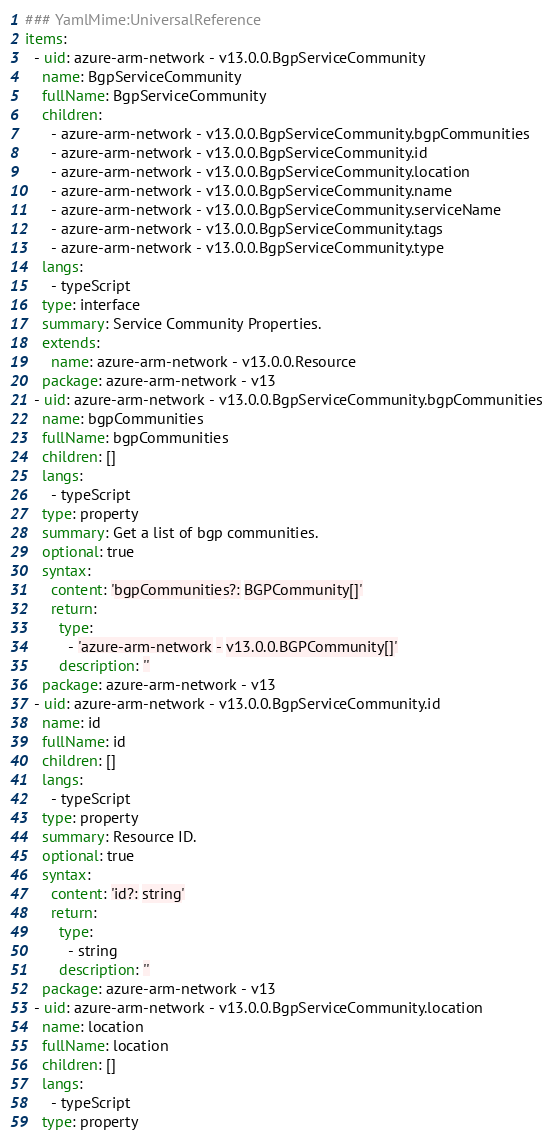<code> <loc_0><loc_0><loc_500><loc_500><_YAML_>### YamlMime:UniversalReference
items:
  - uid: azure-arm-network - v13.0.0.BgpServiceCommunity
    name: BgpServiceCommunity
    fullName: BgpServiceCommunity
    children:
      - azure-arm-network - v13.0.0.BgpServiceCommunity.bgpCommunities
      - azure-arm-network - v13.0.0.BgpServiceCommunity.id
      - azure-arm-network - v13.0.0.BgpServiceCommunity.location
      - azure-arm-network - v13.0.0.BgpServiceCommunity.name
      - azure-arm-network - v13.0.0.BgpServiceCommunity.serviceName
      - azure-arm-network - v13.0.0.BgpServiceCommunity.tags
      - azure-arm-network - v13.0.0.BgpServiceCommunity.type
    langs:
      - typeScript
    type: interface
    summary: Service Community Properties.
    extends:
      name: azure-arm-network - v13.0.0.Resource
    package: azure-arm-network - v13
  - uid: azure-arm-network - v13.0.0.BgpServiceCommunity.bgpCommunities
    name: bgpCommunities
    fullName: bgpCommunities
    children: []
    langs:
      - typeScript
    type: property
    summary: Get a list of bgp communities.
    optional: true
    syntax:
      content: 'bgpCommunities?: BGPCommunity[]'
      return:
        type:
          - 'azure-arm-network - v13.0.0.BGPCommunity[]'
        description: ''
    package: azure-arm-network - v13
  - uid: azure-arm-network - v13.0.0.BgpServiceCommunity.id
    name: id
    fullName: id
    children: []
    langs:
      - typeScript
    type: property
    summary: Resource ID.
    optional: true
    syntax:
      content: 'id?: string'
      return:
        type:
          - string
        description: ''
    package: azure-arm-network - v13
  - uid: azure-arm-network - v13.0.0.BgpServiceCommunity.location
    name: location
    fullName: location
    children: []
    langs:
      - typeScript
    type: property</code> 